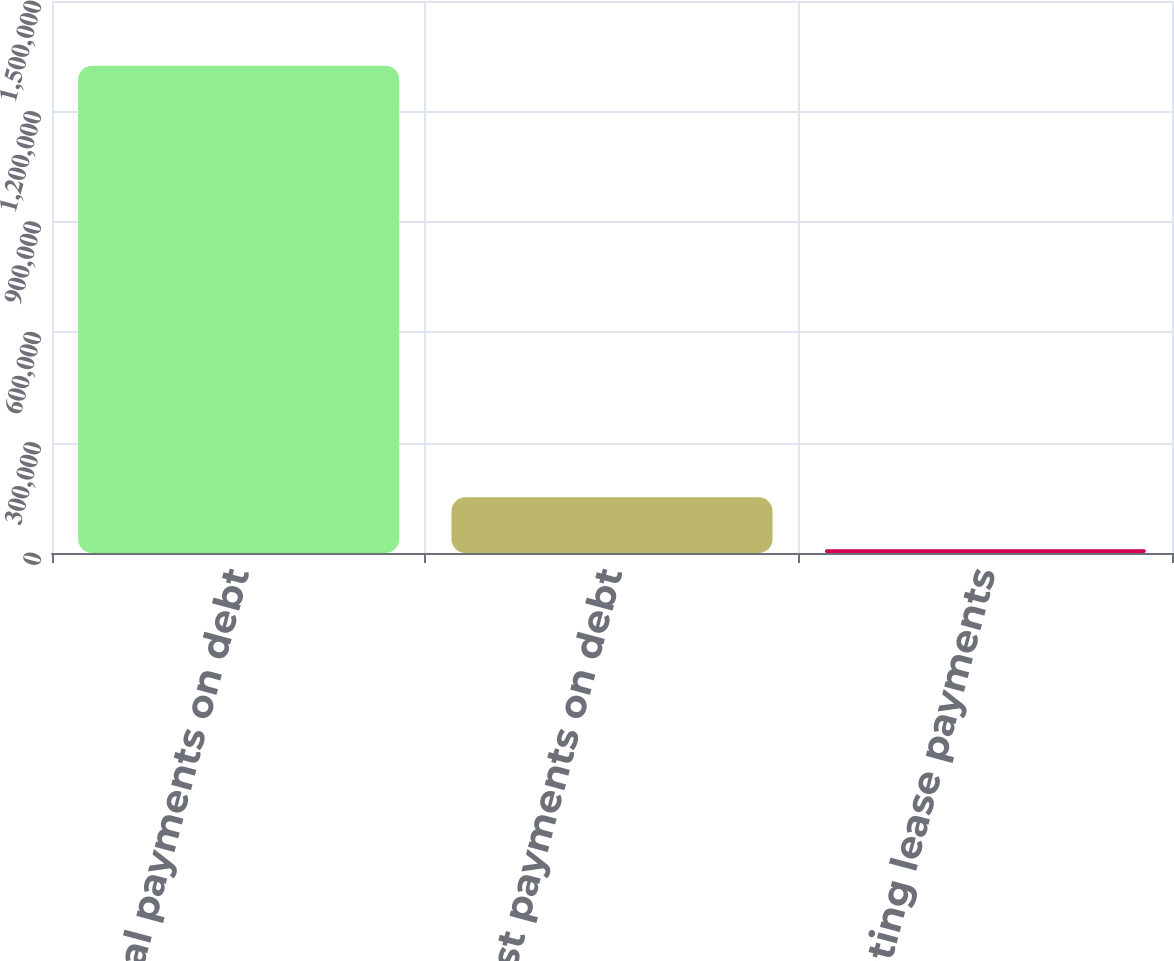Convert chart to OTSL. <chart><loc_0><loc_0><loc_500><loc_500><bar_chart><fcel>Principal payments on debt<fcel>Interest payments on debt<fcel>Operating lease payments<nl><fcel>1.32414e+06<fcel>151263<fcel>10206<nl></chart> 